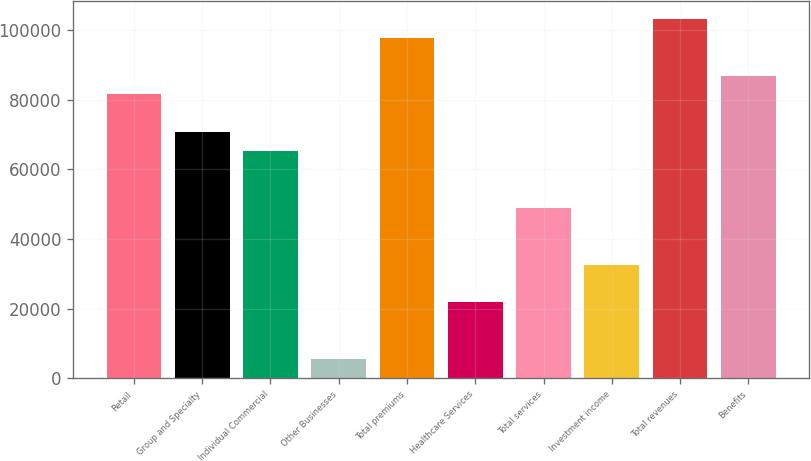Convert chart. <chart><loc_0><loc_0><loc_500><loc_500><bar_chart><fcel>Retail<fcel>Group and Specialty<fcel>Individual Commercial<fcel>Other Businesses<fcel>Total premiums<fcel>Healthcare Services<fcel>Total services<fcel>Investment income<fcel>Total revenues<fcel>Benefits<nl><fcel>81566.4<fcel>70691.4<fcel>65253.9<fcel>5441.56<fcel>97878.9<fcel>21754<fcel>48941.5<fcel>32629<fcel>103316<fcel>87003.9<nl></chart> 